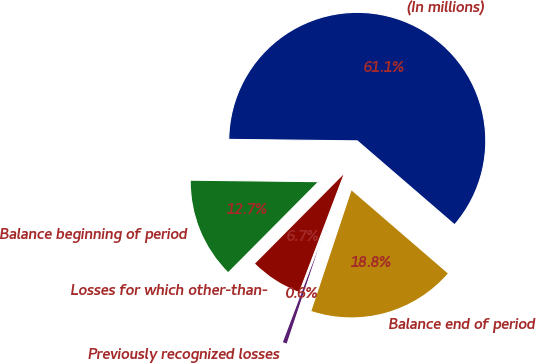Convert chart. <chart><loc_0><loc_0><loc_500><loc_500><pie_chart><fcel>(In millions)<fcel>Balance beginning of period<fcel>Losses for which other-than-<fcel>Previously recognized losses<fcel>Balance end of period<nl><fcel>61.14%<fcel>12.74%<fcel>6.69%<fcel>0.64%<fcel>18.79%<nl></chart> 